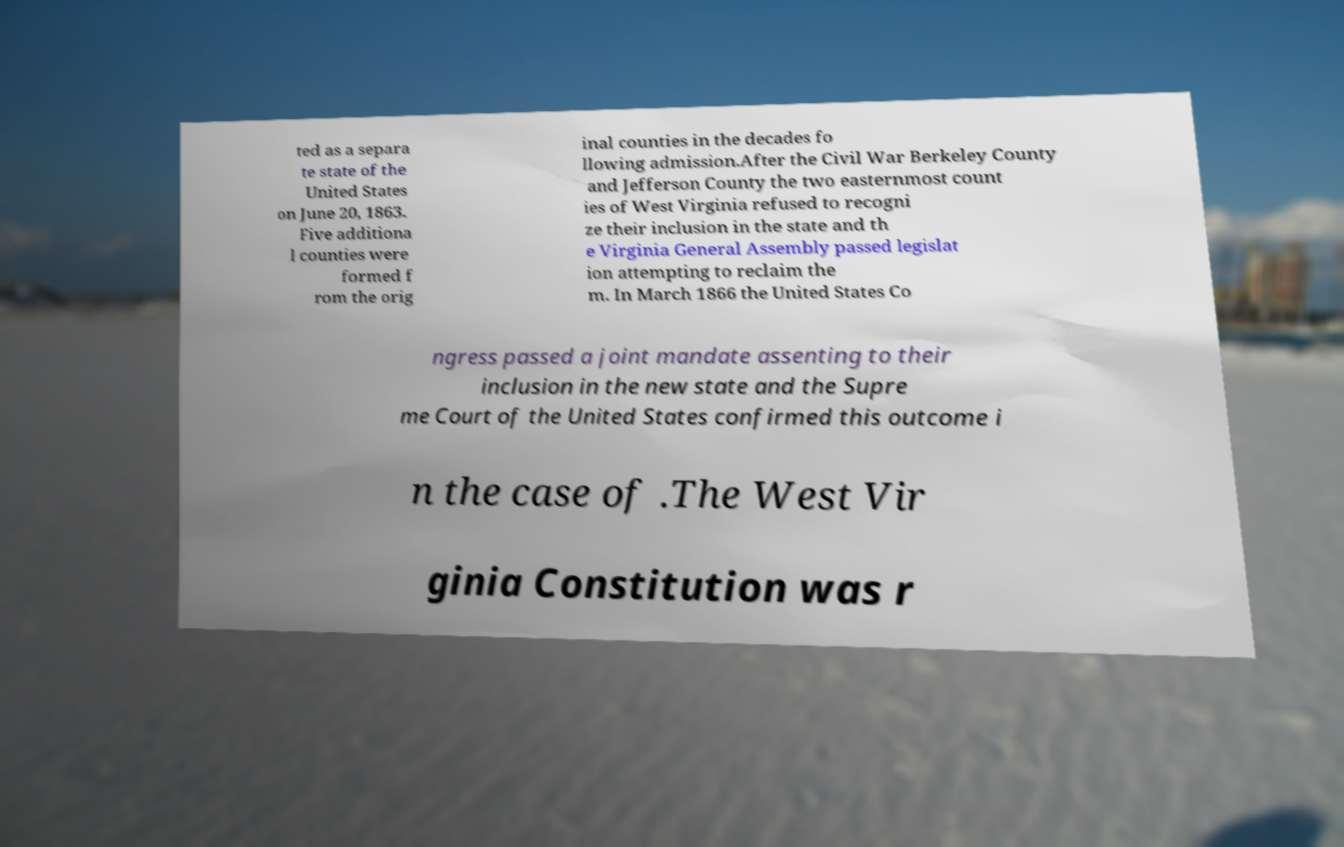What messages or text are displayed in this image? I need them in a readable, typed format. ted as a separa te state of the United States on June 20, 1863. Five additiona l counties were formed f rom the orig inal counties in the decades fo llowing admission.After the Civil War Berkeley County and Jefferson County the two easternmost count ies of West Virginia refused to recogni ze their inclusion in the state and th e Virginia General Assembly passed legislat ion attempting to reclaim the m. In March 1866 the United States Co ngress passed a joint mandate assenting to their inclusion in the new state and the Supre me Court of the United States confirmed this outcome i n the case of .The West Vir ginia Constitution was r 